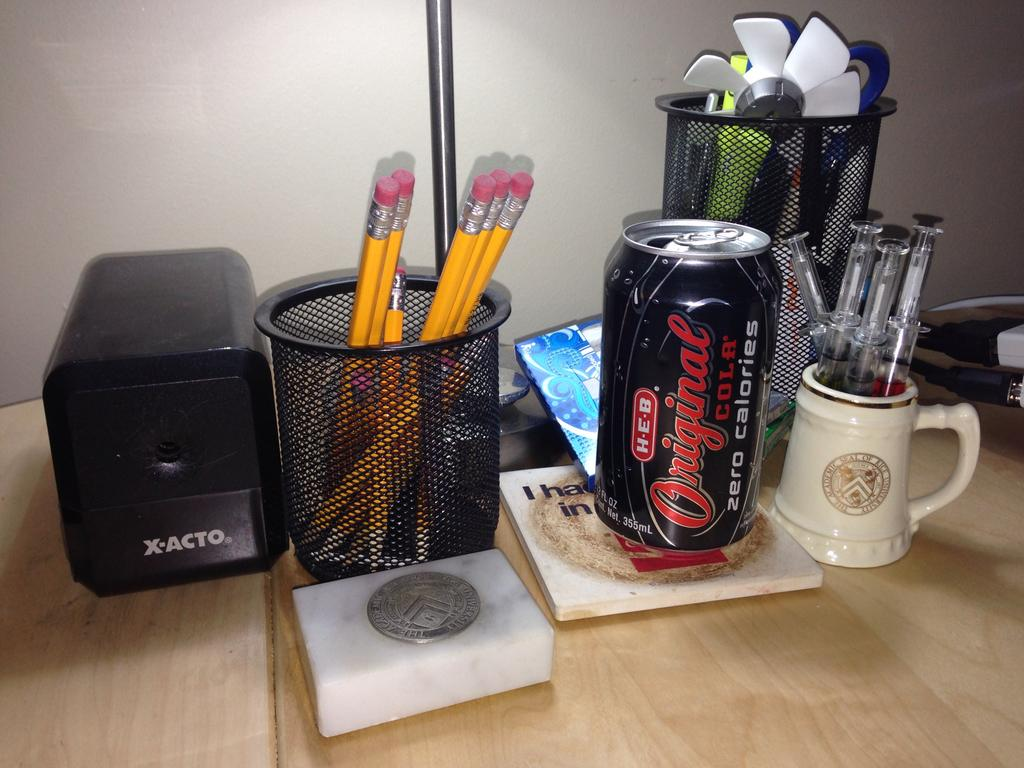<image>
Describe the image concisely. Black Original Cola can in between some pencils and syringes. 